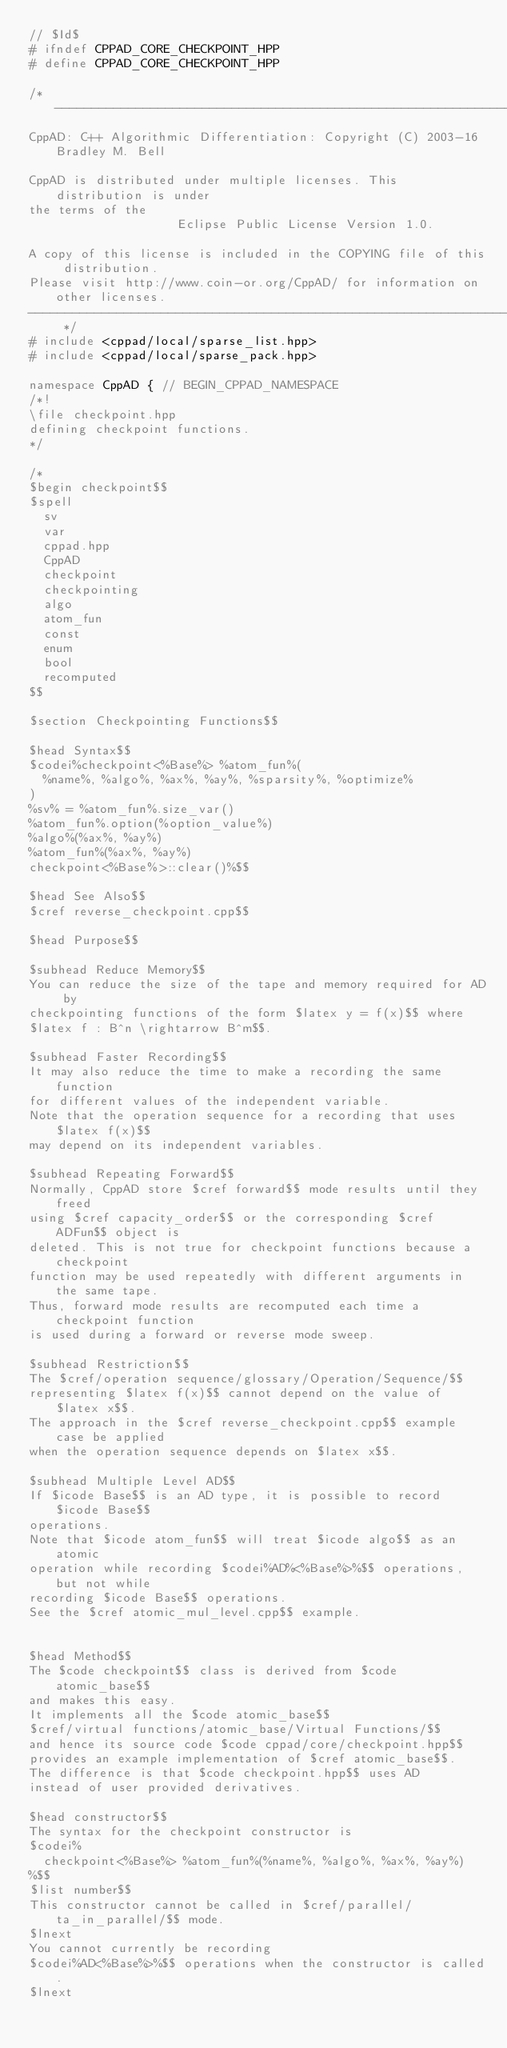<code> <loc_0><loc_0><loc_500><loc_500><_C++_>// $Id$
# ifndef CPPAD_CORE_CHECKPOINT_HPP
# define CPPAD_CORE_CHECKPOINT_HPP

/* --------------------------------------------------------------------------
CppAD: C++ Algorithmic Differentiation: Copyright (C) 2003-16 Bradley M. Bell

CppAD is distributed under multiple licenses. This distribution is under
the terms of the
                    Eclipse Public License Version 1.0.

A copy of this license is included in the COPYING file of this distribution.
Please visit http://www.coin-or.org/CppAD/ for information on other licenses.
-------------------------------------------------------------------------- */
# include <cppad/local/sparse_list.hpp>
# include <cppad/local/sparse_pack.hpp>

namespace CppAD { // BEGIN_CPPAD_NAMESPACE
/*!
\file checkpoint.hpp
defining checkpoint functions.
*/

/*
$begin checkpoint$$
$spell
	sv
	var
	cppad.hpp
	CppAD
	checkpoint
	checkpointing
	algo
	atom_fun
	const
	enum
	bool
	recomputed
$$

$section Checkpointing Functions$$

$head Syntax$$
$codei%checkpoint<%Base%> %atom_fun%(
	%name%, %algo%, %ax%, %ay%, %sparsity%, %optimize%
)
%sv% = %atom_fun%.size_var()
%atom_fun%.option(%option_value%)
%algo%(%ax%, %ay%)
%atom_fun%(%ax%, %ay%)
checkpoint<%Base%>::clear()%$$

$head See Also$$
$cref reverse_checkpoint.cpp$$

$head Purpose$$

$subhead Reduce Memory$$
You can reduce the size of the tape and memory required for AD by
checkpointing functions of the form $latex y = f(x)$$ where
$latex f : B^n \rightarrow B^m$$.

$subhead Faster Recording$$
It may also reduce the time to make a recording the same function
for different values of the independent variable.
Note that the operation sequence for a recording that uses $latex f(x)$$
may depend on its independent variables.

$subhead Repeating Forward$$
Normally, CppAD store $cref forward$$ mode results until they freed
using $cref capacity_order$$ or the corresponding $cref ADFun$$ object is
deleted. This is not true for checkpoint functions because a checkpoint
function may be used repeatedly with different arguments in the same tape.
Thus, forward mode results are recomputed each time a checkpoint function
is used during a forward or reverse mode sweep.

$subhead Restriction$$
The $cref/operation sequence/glossary/Operation/Sequence/$$
representing $latex f(x)$$ cannot depend on the value of $latex x$$.
The approach in the $cref reverse_checkpoint.cpp$$ example case be applied
when the operation sequence depends on $latex x$$.

$subhead Multiple Level AD$$
If $icode Base$$ is an AD type, it is possible to record $icode Base$$
operations.
Note that $icode atom_fun$$ will treat $icode algo$$ as an atomic
operation while recording $codei%AD%<%Base%>%$$ operations, but not while
recording $icode Base$$ operations.
See the $cref atomic_mul_level.cpp$$ example.


$head Method$$
The $code checkpoint$$ class is derived from $code atomic_base$$
and makes this easy.
It implements all the $code atomic_base$$
$cref/virtual functions/atomic_base/Virtual Functions/$$
and hence its source code $code cppad/core/checkpoint.hpp$$
provides an example implementation of $cref atomic_base$$.
The difference is that $code checkpoint.hpp$$ uses AD
instead of user provided derivatives.

$head constructor$$
The syntax for the checkpoint constructor is
$codei%
	checkpoint<%Base%> %atom_fun%(%name%, %algo%, %ax%, %ay%)
%$$
$list number$$
This constructor cannot be called in $cref/parallel/ta_in_parallel/$$ mode.
$lnext
You cannot currently be recording
$codei%AD<%Base%>%$$ operations when the constructor is called.
$lnext</code> 